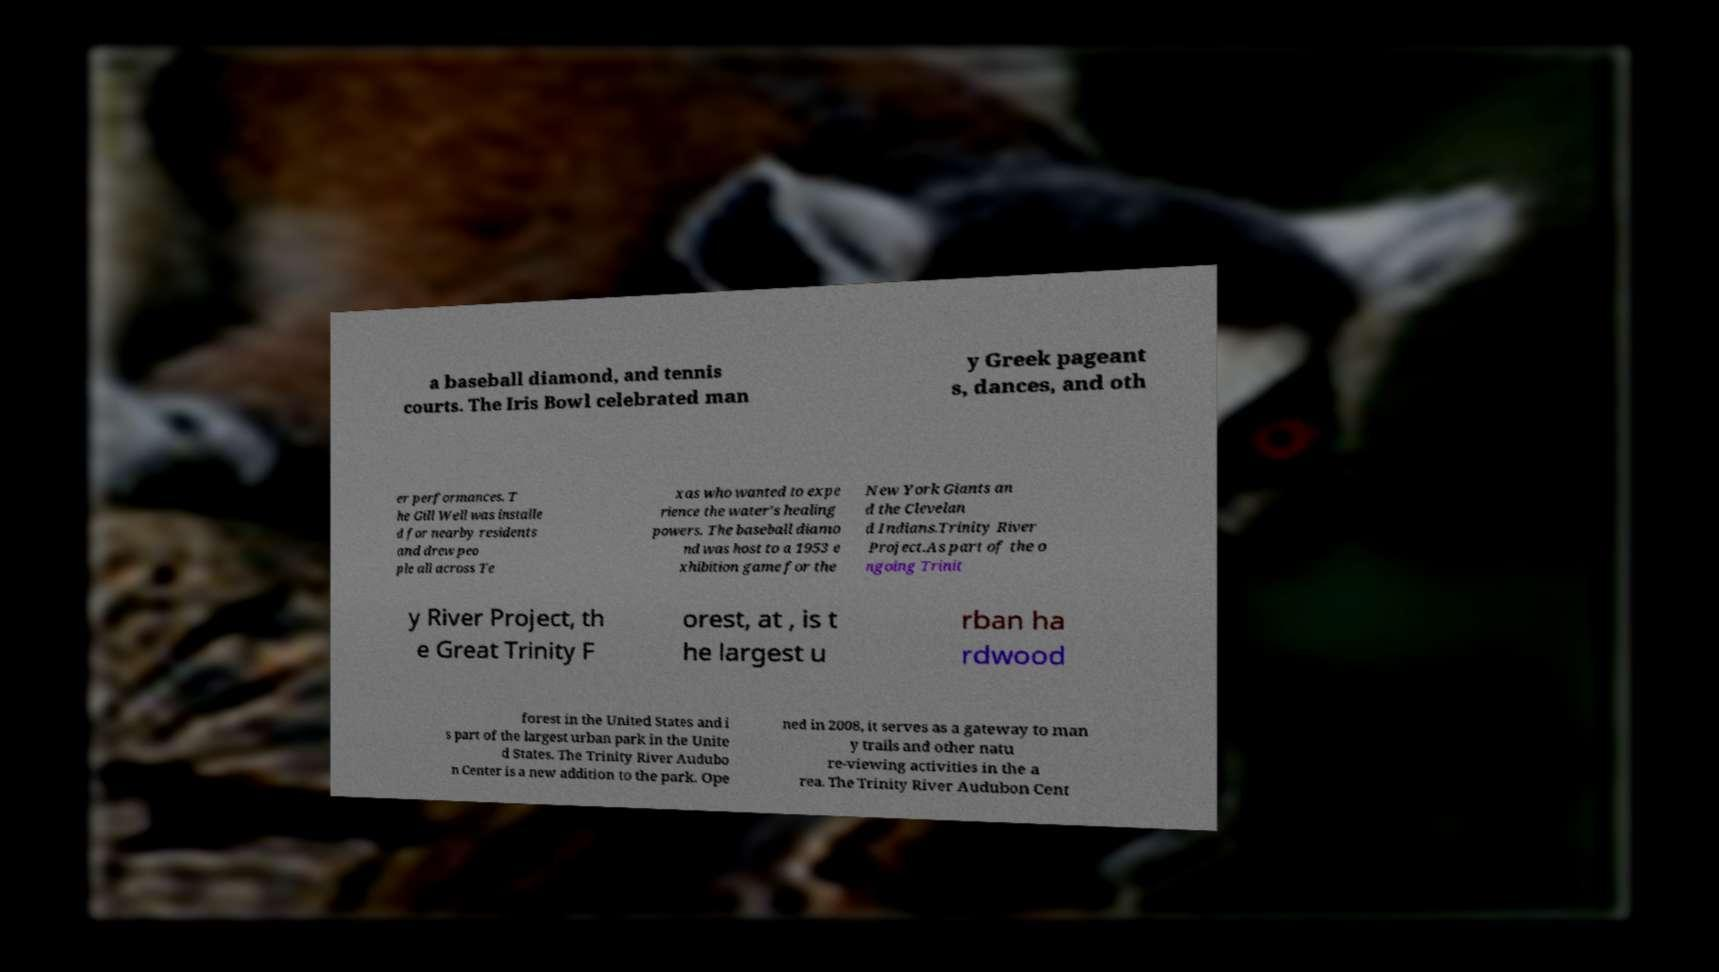There's text embedded in this image that I need extracted. Can you transcribe it verbatim? a baseball diamond, and tennis courts. The Iris Bowl celebrated man y Greek pageant s, dances, and oth er performances. T he Gill Well was installe d for nearby residents and drew peo ple all across Te xas who wanted to expe rience the water's healing powers. The baseball diamo nd was host to a 1953 e xhibition game for the New York Giants an d the Clevelan d Indians.Trinity River Project.As part of the o ngoing Trinit y River Project, th e Great Trinity F orest, at , is t he largest u rban ha rdwood forest in the United States and i s part of the largest urban park in the Unite d States. The Trinity River Audubo n Center is a new addition to the park. Ope ned in 2008, it serves as a gateway to man y trails and other natu re-viewing activities in the a rea. The Trinity River Audubon Cent 